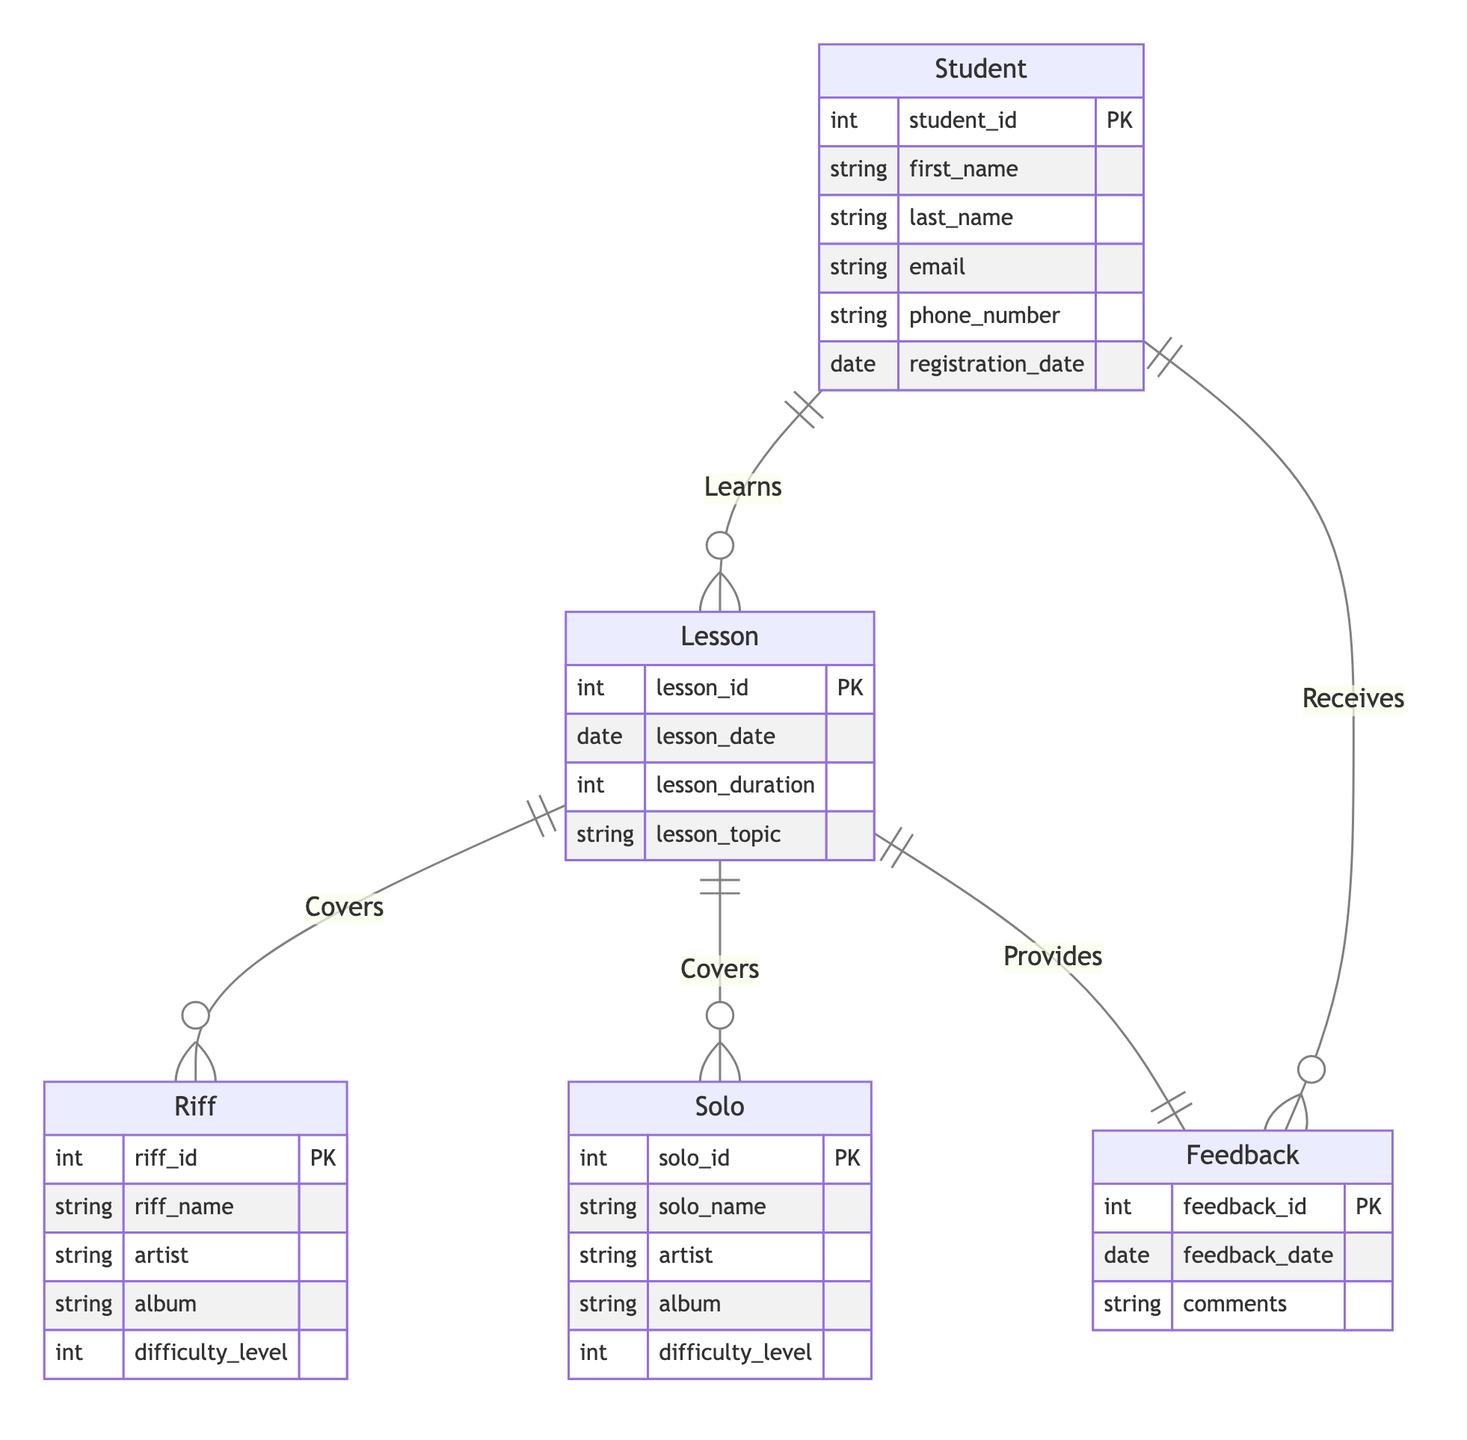What is the primary key of the Student entity? The primary key of the Student entity is student_id, which uniquely identifies each student in the system.
Answer: student_id How many attributes does the Riff entity have? The Riff entity has five attributes, which include riff_id, riff_name, artist, album, and difficulty_level.
Answer: five How many entities are connected by the Learns relationship? The Learns relationship connects two entities: Student and Lesson, indicating that students learn lessons.
Answer: two What type of relationship exists between Lesson and Feedback? The relationship between Lesson and Feedback is a One-to-One relationship, meaning each lesson is associated with exactly one feedback entry.
Answer: One-to-One What is the primary key of the Feedback entity? The primary key of the Feedback entity is feedback_id, which uniquely identifies each feedback entry.
Answer: feedback_id Which entity has a Many-to-Many relationship with Student? The entity that has a Many-to-Many relationship with Student is Lesson, showing that students can enroll in multiple lessons, and lessons can have multiple students.
Answer: Lesson How many Riffs can a single Lesson cover? A single Lesson can cover multiple Riffs, indicating a One-to-Many relationship where one lesson can have many riffs associated with it.
Answer: multiple What is the minimum number of feedback entries a Student can receive? A Student can receive zero feedback entries as there is a One-to-Many relationship between Student and Feedback, meaning they might not receive any feedback at all.
Answer: zero How many entities in the diagram are related to the Lesson entity? The Lesson entity is related to four entities in total: Student, Riff, Solo, and Feedback, indicating its central role in the diagram.
Answer: four 